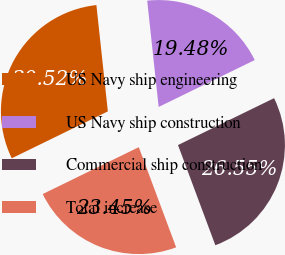Convert chart. <chart><loc_0><loc_0><loc_500><loc_500><pie_chart><fcel>US Navy ship engineering<fcel>US Navy ship construction<fcel>Commercial ship construction<fcel>Total increase<nl><fcel>30.52%<fcel>19.48%<fcel>26.55%<fcel>23.45%<nl></chart> 